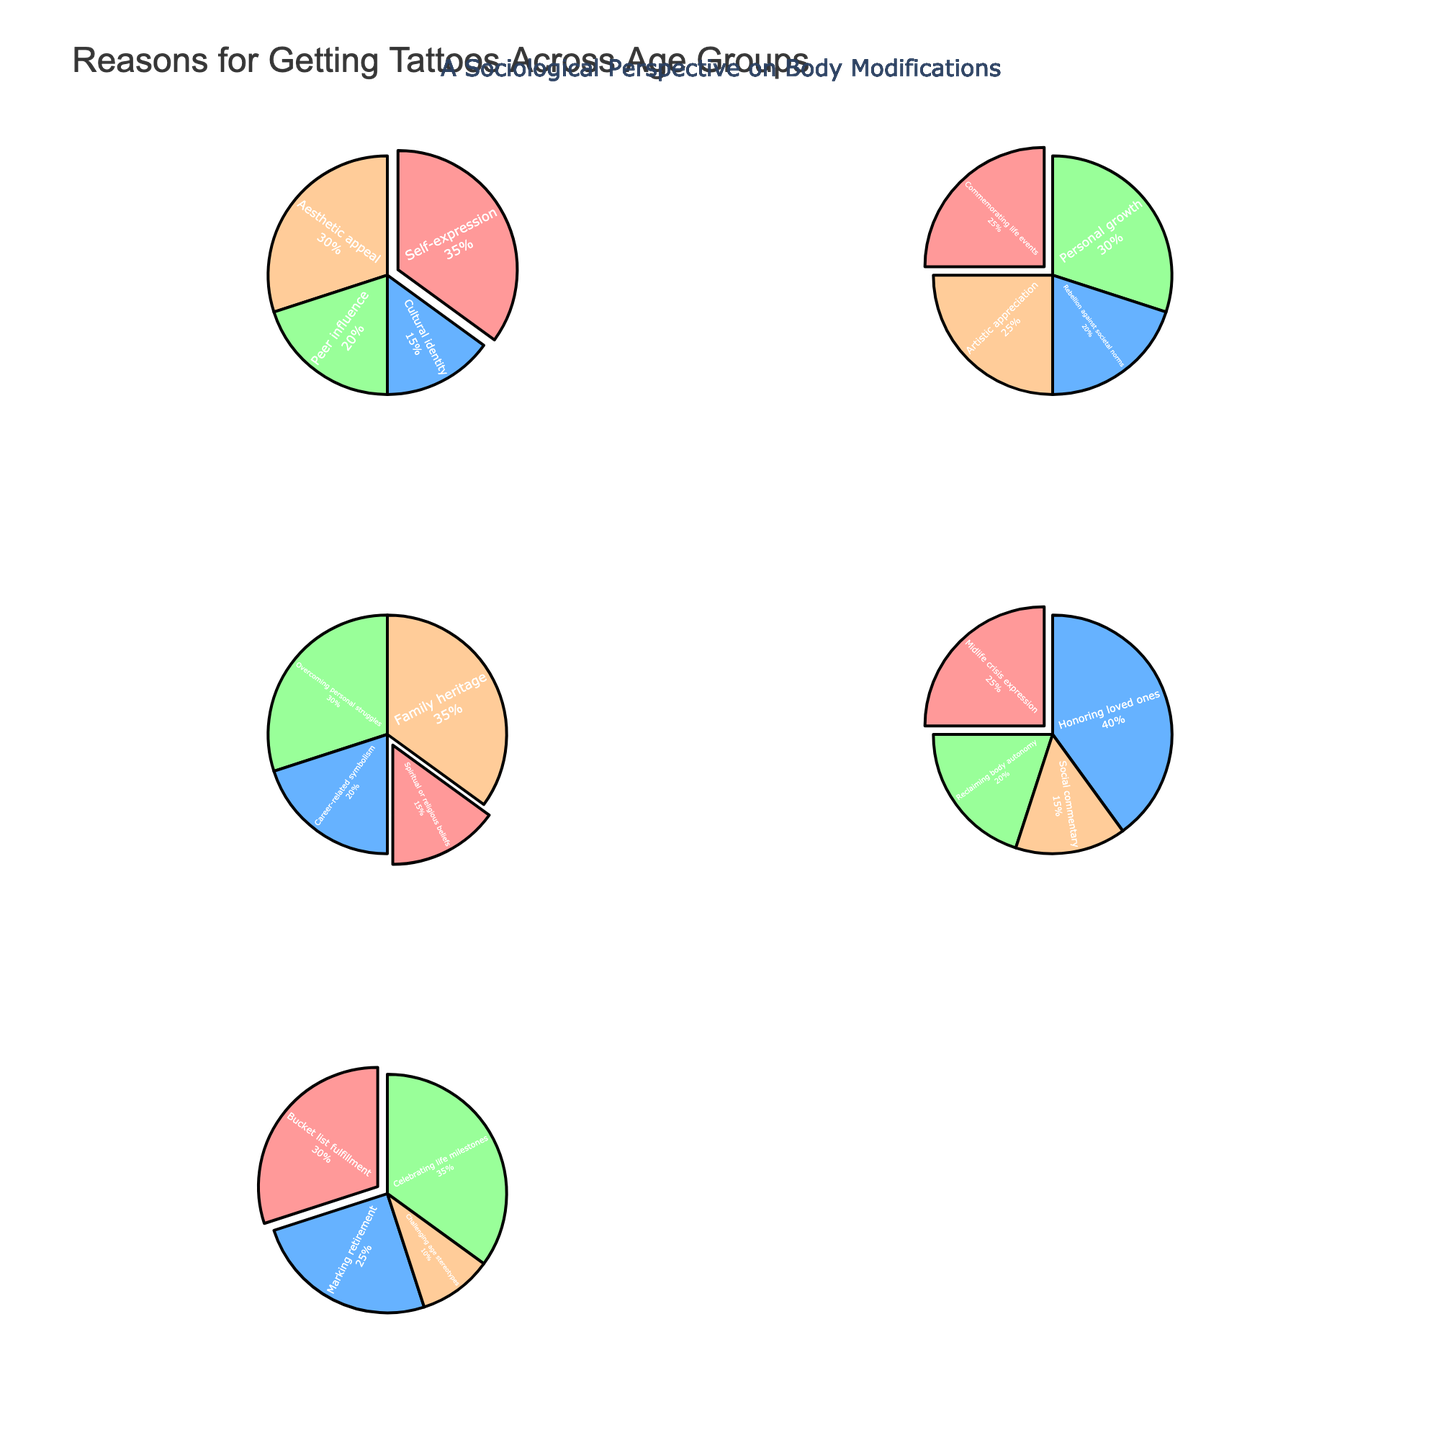What's the most common reason for getting a tattoo among the 45-54 age group? The "Honoring loved ones" segment has the largest proportion in the pie chart for the 45-54 age group.
Answer: Honoring loved ones What percentage of people in the 18-24 age group got tattoos for peer influence? The percentage for "Peer influence" can be directly read off the pie chart for the 18-24 age group.
Answer: 20% What is the total percentage of people citing rebellion against societal norms or personal growth in the 25-34 age group? Sum the percentages for "Rebellion against societal norms" (20%) and "Personal growth" (30%) in the 25-34 age group.
Answer: 50% Which age group cites celebrating life milestones as the reason for getting a tattoo the most? Look at the pie chart segments marked "Celebrating life milestones" across all age groups, the largest one appears in the 55+ age group.
Answer: 55+ Is aesthetic appeal more popular than cultural identity among the 18-24 age group? Compare the sizes of the "Aesthetic appeal" and "Cultural identity" segments in the 18-24 age group pie chart, where "Aesthetic appeal" is larger.
Answer: Yes Which age group has the highest percentage of people getting tattoos to mark retirement? The "Marking retirement" reason is specifically shown in the pie chart for the 55+ age group and not for any others.
Answer: 55+ What is the combined percentage of people citing overcoming personal struggles and career-related symbolism in the 35-44 age group? Add the percentages for "Overcoming personal struggles" (30%) and "Career-related symbolism" (20%) in the 35-44 age group.
Answer: 50% Is the percentage for commemorating life events higher than that for artistic appreciation in the 25-34 age group? Compare the "Commemorating life events" segment (25%) and "Artistic appreciation" segment (25%) in the 25-34 age group pie chart, both are equal.
Answer: No What reason is cited by people 55+ with the second-highest percentage? Look at the reasons listed in the 55+ pie chart and determine that "Marking retirement" (25%) is the second-highest after "Celebrating life milestones" (35%).
Answer: Marking retirement 